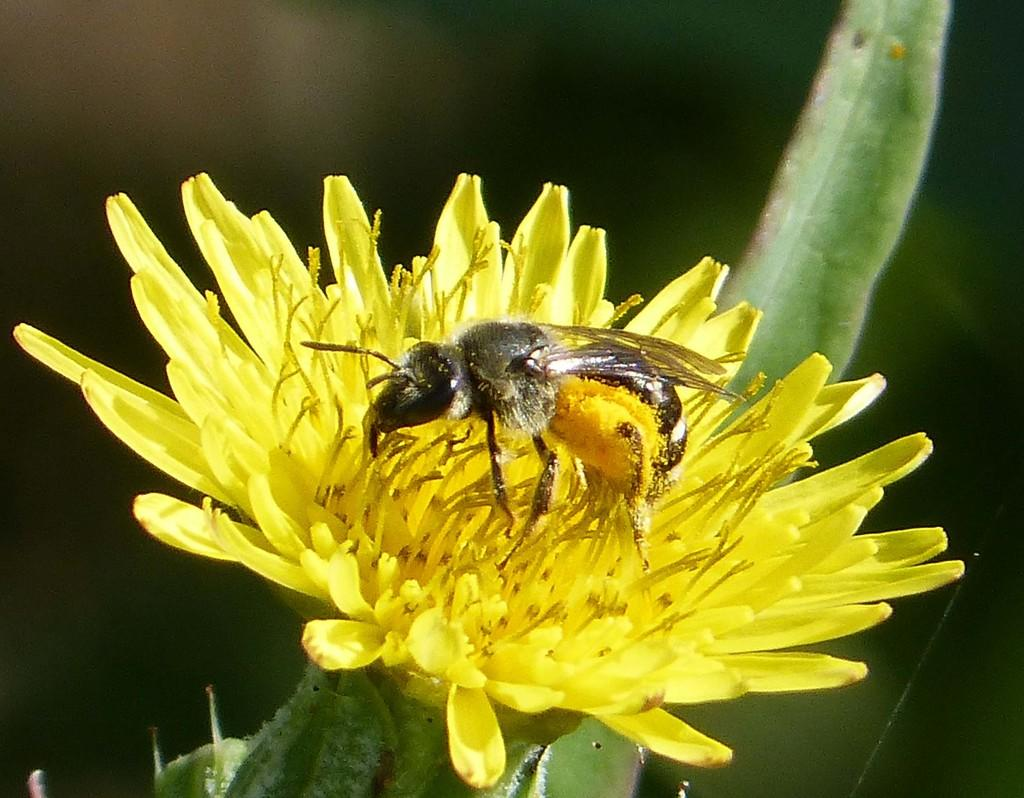What is the main subject in the center of the image? There is a flower in the center of the image. What color is the flower? The flower is yellow in color. Are there any other living organisms present in the image? Yes, there is an insect on the flower. What type of beggar can be seen in the image? A: There is no beggar present in the image; it features a yellow flower with an insect on it. Is there any blood visible in the image? There is no blood present in the image. 